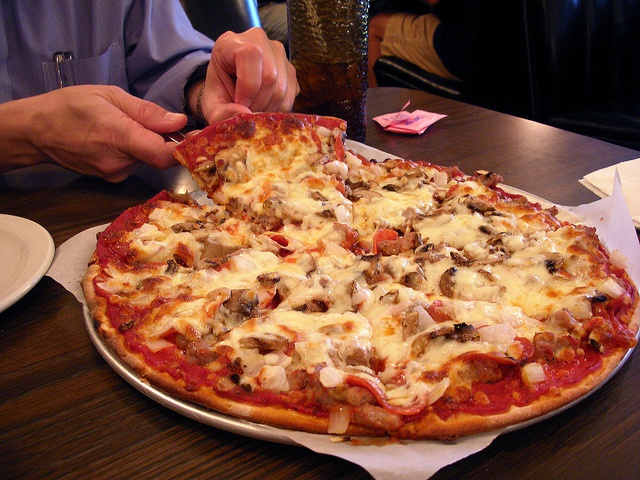Describe the objects in this image and their specific colors. I can see dining table in navy, black, tan, maroon, and brown tones, pizza in navy, tan, and brown tones, people in navy, black, maroon, purple, and salmon tones, people in navy, black, maroon, and brown tones, and cup in navy, black, maroon, and gray tones in this image. 